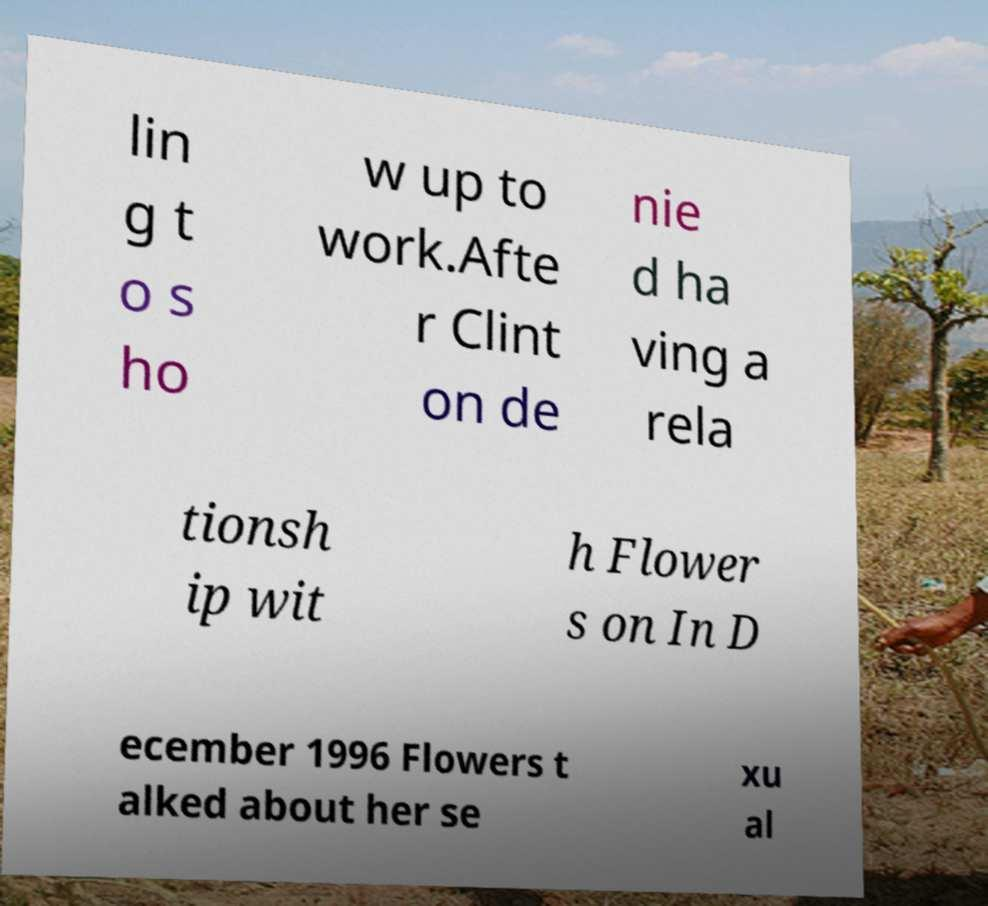Please identify and transcribe the text found in this image. lin g t o s ho w up to work.Afte r Clint on de nie d ha ving a rela tionsh ip wit h Flower s on In D ecember 1996 Flowers t alked about her se xu al 